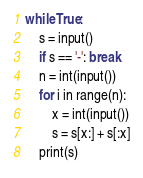Convert code to text. <code><loc_0><loc_0><loc_500><loc_500><_Python_>while True:
    s = input()
    if s == '-': break
    n = int(input())
    for i in range(n):
        x = int(input())
        s = s[x:] + s[:x]
    print(s)

</code> 